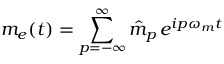<formula> <loc_0><loc_0><loc_500><loc_500>m _ { e } ( t ) = \sum _ { p = - \infty } ^ { \infty } \hat { m } _ { p } \, e ^ { i p \omega _ { m } t }</formula> 